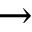Convert formula to latex. <formula><loc_0><loc_0><loc_500><loc_500>\rightarrow</formula> 